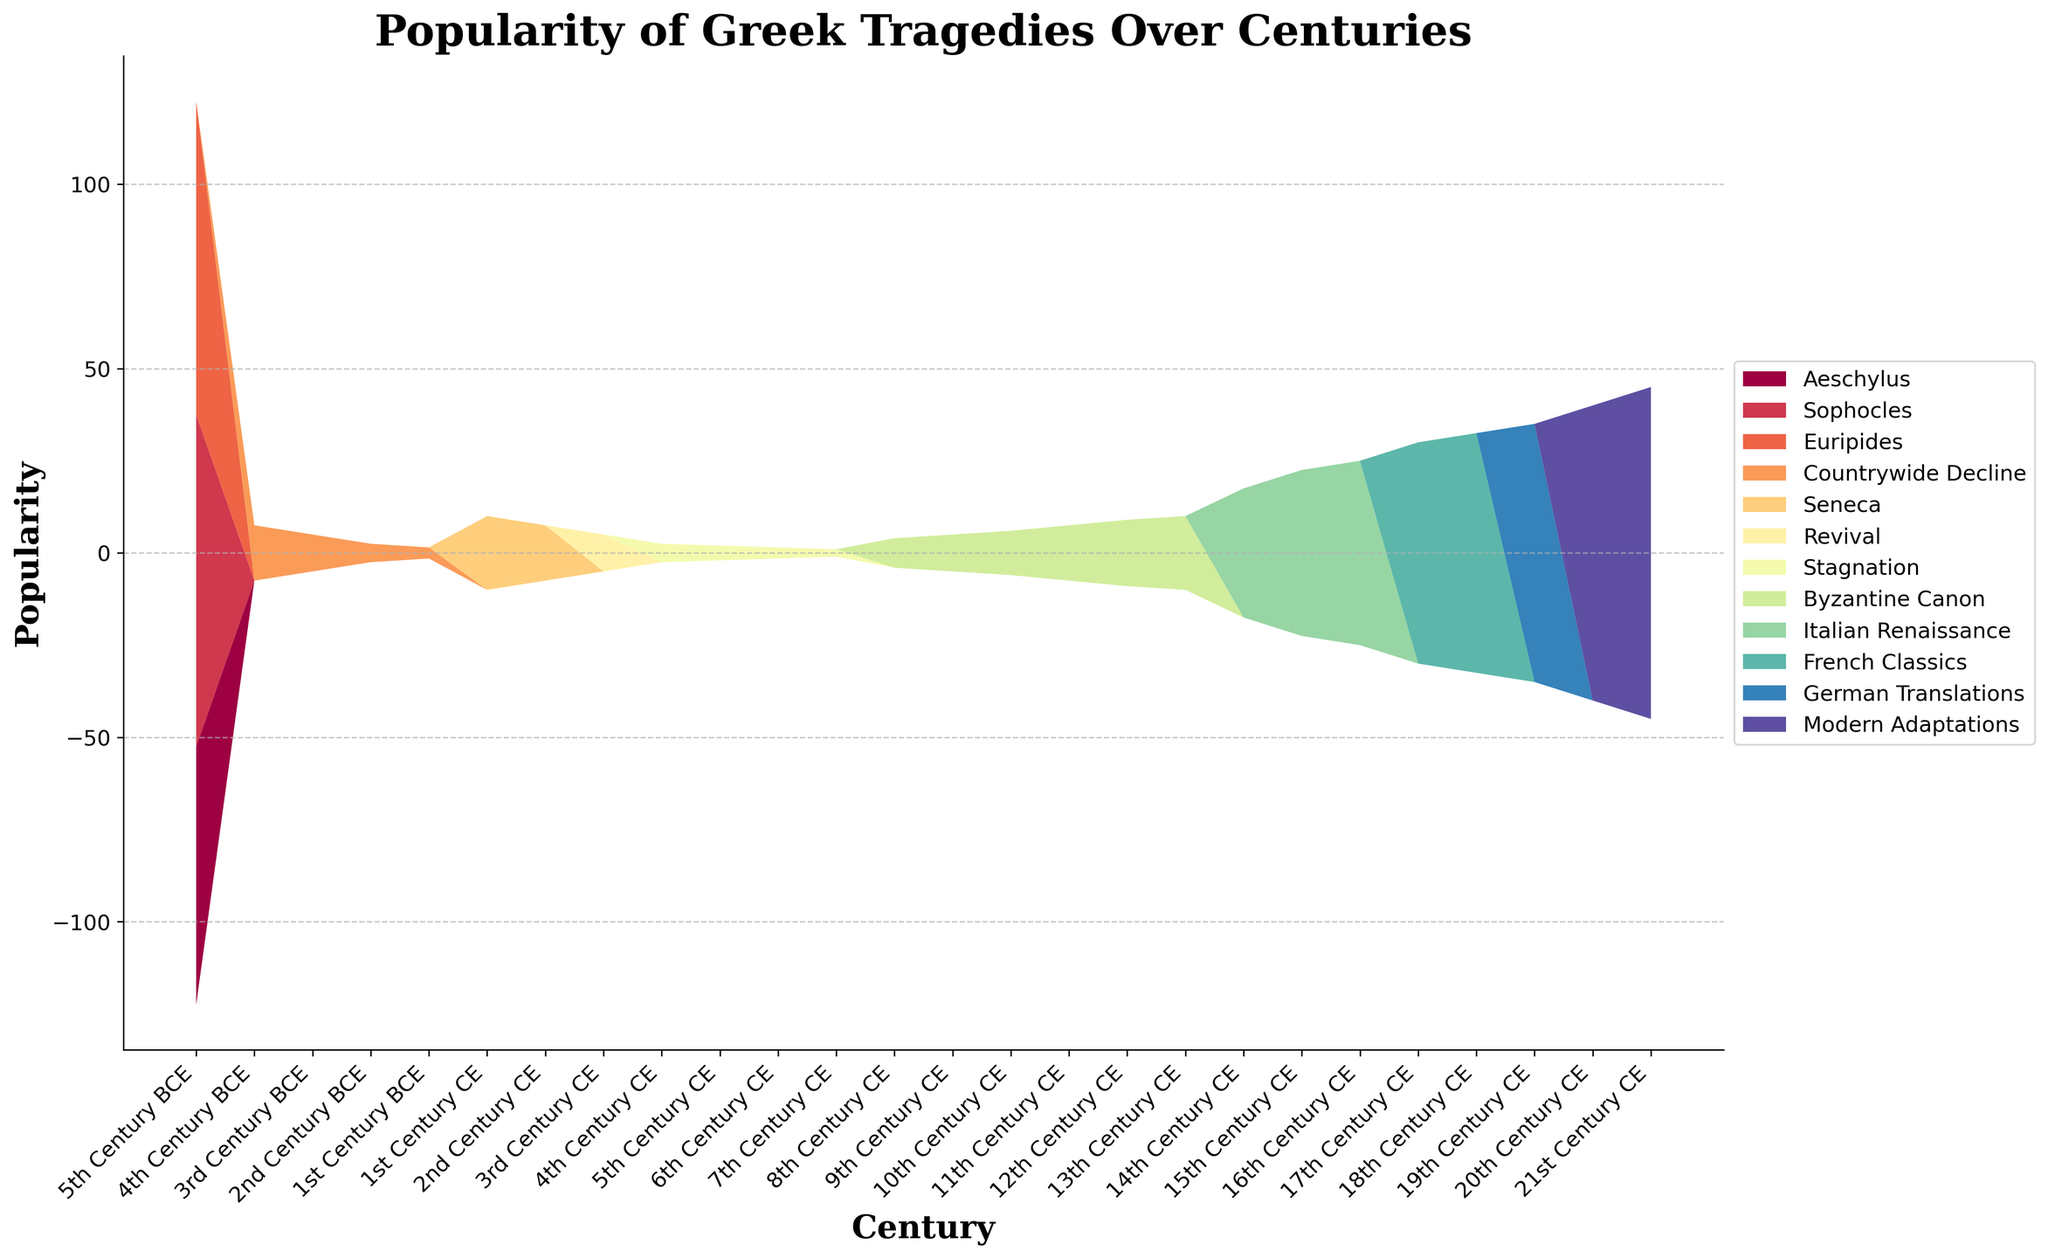What is the title of the plot? The title is usually located at the top of the figure. In this case, it reads "Popularity of Greek Tragedies Over Centuries."
Answer: Popularity of Greek Tragedies Over Centuries Which century saw the peak popularity of Aeschylus' works? Looking at the stream graph, the peak of Aeschylus' segment is in the 5th Century BCE.
Answer: 5th Century BCE Which author continues to have high popularity into the 21st century? The author with an increasing segment reaching into the 21st century is identified as Modern Adaptations.
Answer: Modern Adaptations How did the popularity of Greek tragedies trend overall from the 3rd Century BCE to the 1st Century CE? The segments for all authors show a decline during this period, indicating a general decline in popularity.
Answer: Decline By comparing the 14th and 16th centuries, which period had a higher popularity for Italian Renaissance? The Italian Renaissance segment in the 16th century is visibly higher compared to the 14th century.
Answer: 16th Century CE What is the approximate popularity value for Sophocles in the 5th Century BCE? Locate the Sophocles section in the 5th Century BCE and see the height of the segment, which is around 90.
Answer: 90 Which period shows the least popularity for Greek tragedies? The smallest segments appear in the 7th Century CE during the Stagnation period.
Answer: 7th Century CE Can we observe any revival in popularity after the 7th century CE? Yes, there is a noticeable increase in popularity starting from the 8th century CE, marked by the Byzantine Canon.
Answer: Yes What marks the change in popularity trend at the beginning of the CE (Common Era)? At the turn of the CE, there is a shift where Seneca's segment appears, indicating a change or renewal in interest.
Answer: Seneca How many distinct breakdowns by authors or periods are represented in the figure? Counting the labeled segments, there are roughly 10 distinct breakdowns: Aeschylus, Sophocles, Euripides, Countrywide Decline, Seneca, Revival, Stagnation, Byzantine Canon, Italian Renaissance, French Classics, German Translations, Modern Adaptations.
Answer: 10 